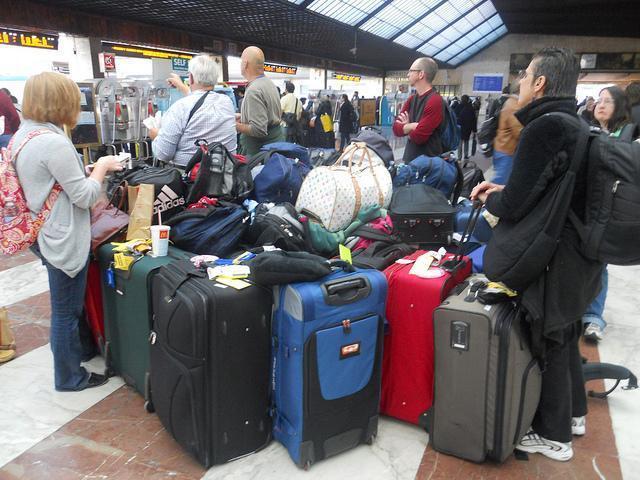How many people can be seen?
Give a very brief answer. 6. How many handbags are there?
Give a very brief answer. 4. How many suitcases are visible?
Give a very brief answer. 7. How many backpacks are there?
Give a very brief answer. 6. How many orange trucks are there?
Give a very brief answer. 0. 